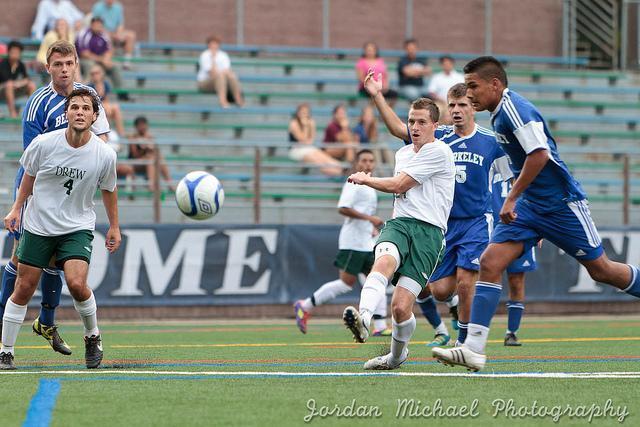How many people are visible?
Give a very brief answer. 8. 